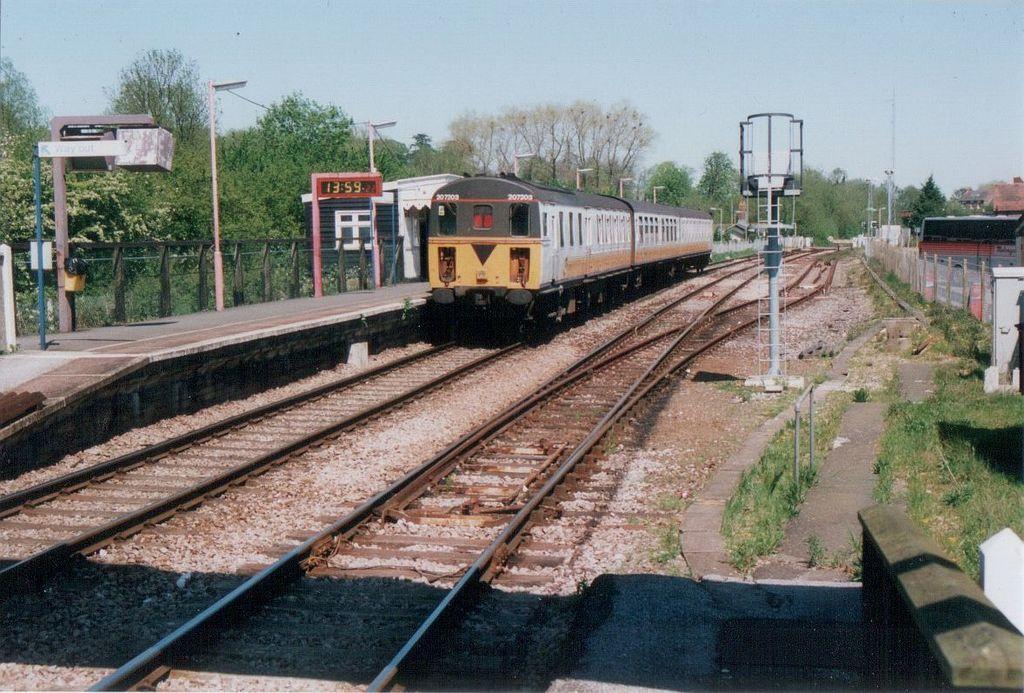Could you give a brief overview of what you see in this image? This is an outside view. In the middle of the image there is a train on the railway track. On the left side there is a platform. Here I can see many poles. On the right side there is a fencing and also I can see few buildings. In the background there are many trees. At the top of the image I can see the sky. 